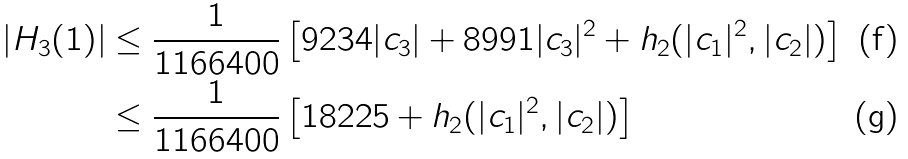<formula> <loc_0><loc_0><loc_500><loc_500>| H _ { 3 } ( 1 ) | & \leq \frac { 1 } { 1 1 6 6 4 0 0 } \left [ 9 2 3 4 | c _ { 3 } | + 8 9 9 1 | c _ { 3 } | ^ { 2 } + h _ { 2 } ( | c _ { 1 } | ^ { 2 } , | c _ { 2 } | ) \right ] \\ & \leq \frac { 1 } { 1 1 6 6 4 0 0 } \left [ 1 8 2 2 5 + h _ { 2 } ( | c _ { 1 } | ^ { 2 } , | c _ { 2 } | ) \right ] \,</formula> 